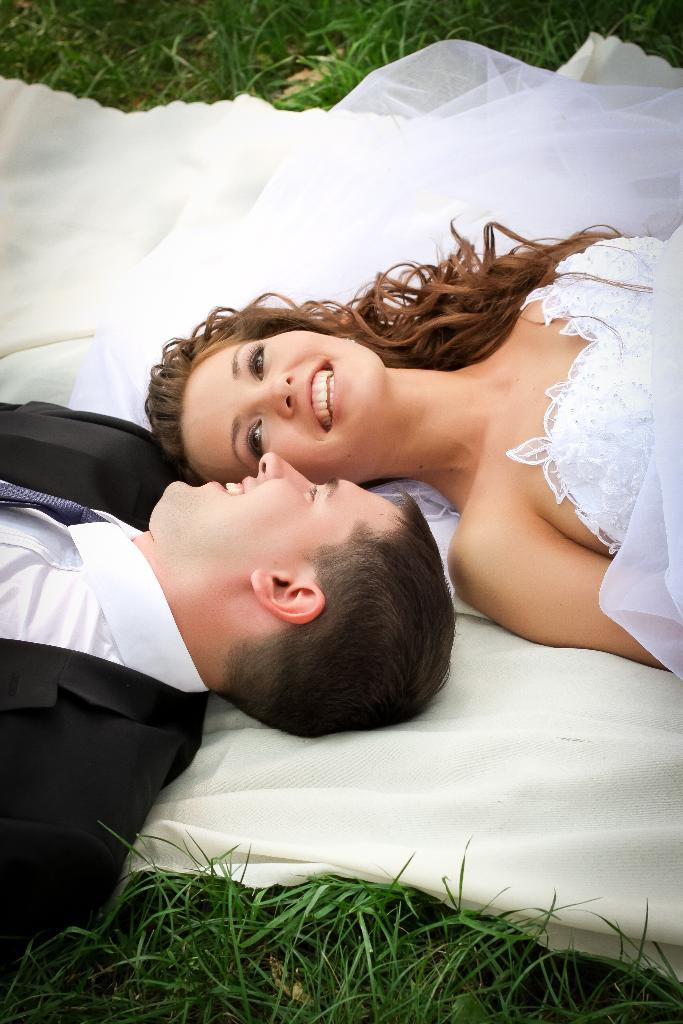How many people are lying on the cloth in the image? There are two persons lying on the cloth. What type of surface is visible beside the cloth? There is grass visible beside the cloth. Can you tell me what request the grandmother made in the image? There is no grandmother present in the image, and therefore no such request can be observed. 